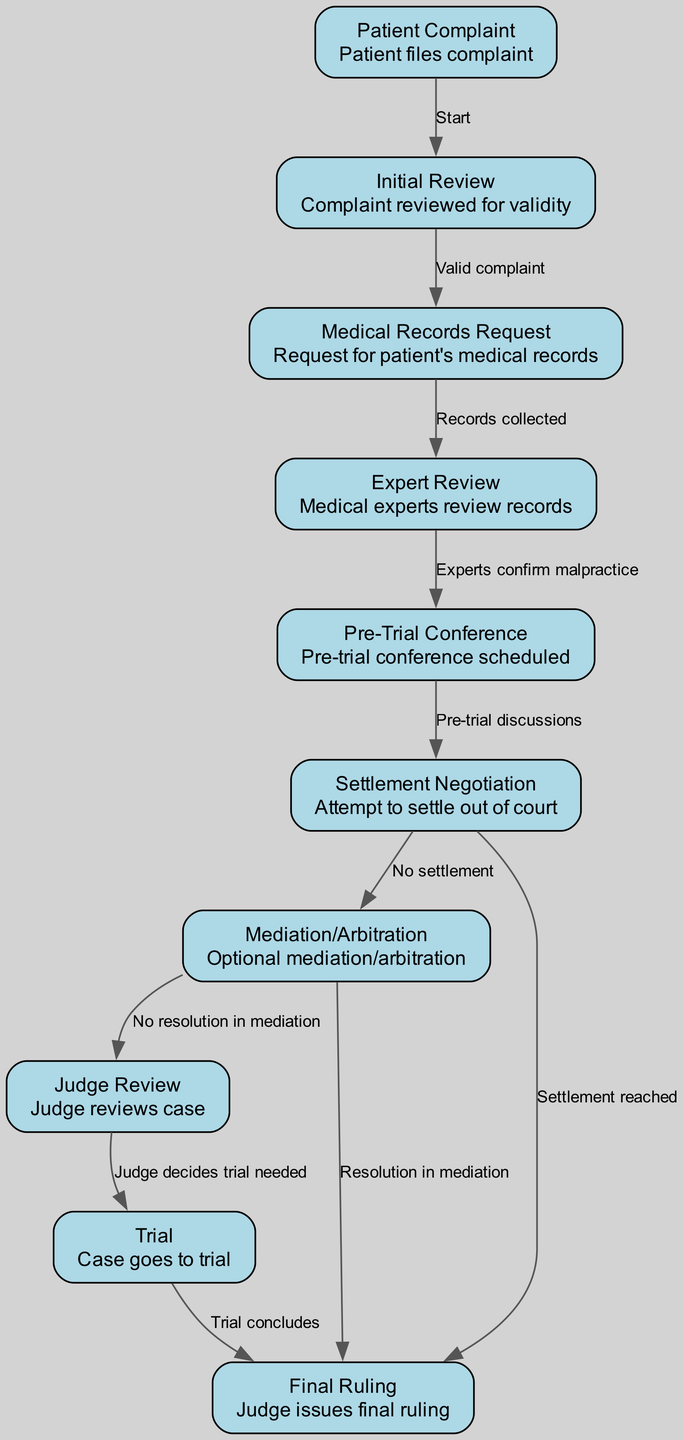What is the first step in the workflow? The diagram starts with "Patient Complaint," indicating that this is the initial step where a patient files a complaint.
Answer: Patient Complaint How many decision points are there in the workflow? The workflow has multiple paths that represent decision points: "Valid complaint," "No settlement," "No resolution in mediation," and whether a trial is needed, totaling four decision points.
Answer: Four What is the outcome if a settlement is reached during the settlement negotiation? According to the diagram, if a settlement is reached, the process leads directly from "Settlement Negotiation" to "Final Ruling," indicating that the judge issues a ruling based on the settlement.
Answer: Final Ruling What happens after the expert review confirms malpractice? Once malpractice is confirmed by the medical experts at the "Expert Review" stage, the process moves to the "Pre-Trial Conference" as the next step.
Answer: Pre-Trial Conference How does the workflow conclude if mediation results in a resolution? If mediation results in a resolution, the process flows from "Mediation/Arbitration" directly to "Final Ruling," where the judge issues the final ruling based on the mediation outcome.
Answer: Final Ruling In the case that a trial is deemed necessary, which step follows after the judge’s review? If the judge decides that a trial is necessary after reviewing the case, the next step is "Trial," where the case goes to trial.
Answer: Trial What step occurs between the Initial Review and Medical Records Request? The "Initial Review" is directly linked to the "Medical Records Request," meaning that there is no step in between them; the next step is immediately the request for medical records.
Answer: Medical Records Request How many total nodes are present in the workflow? By counting the nodes in the diagram, there are ten distinct nodes that represent the various stages in the judicial review workflow for medical malpractice cases.
Answer: Ten What signifies that a complaint has been deemed valid? The edge labeled "Valid complaint" connects "Initial Review" to "Medical Records Request," indicating that validity is confirmed before moving on to the next step.
Answer: Valid complaint 